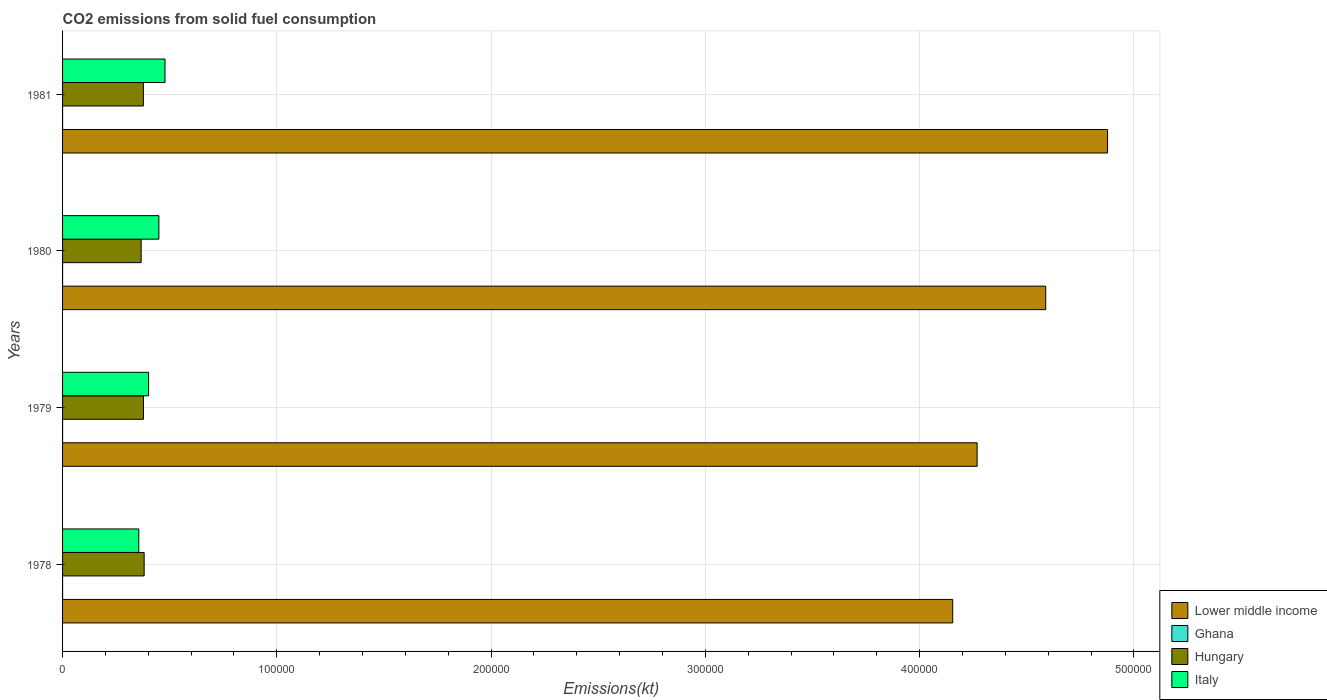How many groups of bars are there?
Offer a terse response. 4. How many bars are there on the 2nd tick from the bottom?
Give a very brief answer. 4. What is the label of the 1st group of bars from the top?
Your answer should be very brief. 1981. What is the amount of CO2 emitted in Ghana in 1980?
Give a very brief answer. 3.67. Across all years, what is the maximum amount of CO2 emitted in Ghana?
Provide a short and direct response. 3.67. Across all years, what is the minimum amount of CO2 emitted in Italy?
Keep it short and to the point. 3.56e+04. In which year was the amount of CO2 emitted in Lower middle income minimum?
Offer a very short reply. 1978. What is the total amount of CO2 emitted in Italy in the graph?
Ensure brevity in your answer.  1.68e+05. What is the difference between the amount of CO2 emitted in Hungary in 1980 and that in 1981?
Ensure brevity in your answer.  -1045.09. What is the difference between the amount of CO2 emitted in Lower middle income in 1981 and the amount of CO2 emitted in Hungary in 1979?
Provide a short and direct response. 4.50e+05. What is the average amount of CO2 emitted in Hungary per year?
Give a very brief answer. 3.76e+04. In the year 1980, what is the difference between the amount of CO2 emitted in Italy and amount of CO2 emitted in Ghana?
Keep it short and to the point. 4.49e+04. What is the ratio of the amount of CO2 emitted in Italy in 1978 to that in 1979?
Your answer should be very brief. 0.89. Is the amount of CO2 emitted in Ghana in 1978 less than that in 1979?
Offer a terse response. No. Is the difference between the amount of CO2 emitted in Italy in 1979 and 1980 greater than the difference between the amount of CO2 emitted in Ghana in 1979 and 1980?
Offer a very short reply. No. What is the difference between the highest and the second highest amount of CO2 emitted in Italy?
Provide a succinct answer. 2860.26. What is the difference between the highest and the lowest amount of CO2 emitted in Ghana?
Your answer should be very brief. 0. Is it the case that in every year, the sum of the amount of CO2 emitted in Ghana and amount of CO2 emitted in Hungary is greater than the sum of amount of CO2 emitted in Lower middle income and amount of CO2 emitted in Italy?
Your answer should be very brief. Yes. What does the 4th bar from the top in 1978 represents?
Your answer should be very brief. Lower middle income. What does the 3rd bar from the bottom in 1981 represents?
Your response must be concise. Hungary. Is it the case that in every year, the sum of the amount of CO2 emitted in Italy and amount of CO2 emitted in Ghana is greater than the amount of CO2 emitted in Hungary?
Your answer should be very brief. No. How many bars are there?
Your response must be concise. 16. Are all the bars in the graph horizontal?
Make the answer very short. Yes. What is the difference between two consecutive major ticks on the X-axis?
Offer a terse response. 1.00e+05. Are the values on the major ticks of X-axis written in scientific E-notation?
Offer a very short reply. No. Does the graph contain grids?
Offer a very short reply. Yes. What is the title of the graph?
Offer a terse response. CO2 emissions from solid fuel consumption. Does "Bahrain" appear as one of the legend labels in the graph?
Your answer should be very brief. No. What is the label or title of the X-axis?
Your answer should be compact. Emissions(kt). What is the label or title of the Y-axis?
Keep it short and to the point. Years. What is the Emissions(kt) of Lower middle income in 1978?
Your response must be concise. 4.15e+05. What is the Emissions(kt) of Ghana in 1978?
Your answer should be compact. 3.67. What is the Emissions(kt) of Hungary in 1978?
Your answer should be very brief. 3.81e+04. What is the Emissions(kt) of Italy in 1978?
Your response must be concise. 3.56e+04. What is the Emissions(kt) of Lower middle income in 1979?
Your response must be concise. 4.27e+05. What is the Emissions(kt) of Ghana in 1979?
Offer a terse response. 3.67. What is the Emissions(kt) of Hungary in 1979?
Offer a terse response. 3.78e+04. What is the Emissions(kt) of Italy in 1979?
Your response must be concise. 4.02e+04. What is the Emissions(kt) in Lower middle income in 1980?
Ensure brevity in your answer.  4.59e+05. What is the Emissions(kt) of Ghana in 1980?
Provide a succinct answer. 3.67. What is the Emissions(kt) of Hungary in 1980?
Give a very brief answer. 3.67e+04. What is the Emissions(kt) of Italy in 1980?
Ensure brevity in your answer.  4.50e+04. What is the Emissions(kt) of Lower middle income in 1981?
Offer a very short reply. 4.88e+05. What is the Emissions(kt) in Ghana in 1981?
Your response must be concise. 3.67. What is the Emissions(kt) in Hungary in 1981?
Make the answer very short. 3.77e+04. What is the Emissions(kt) in Italy in 1981?
Provide a succinct answer. 4.78e+04. Across all years, what is the maximum Emissions(kt) in Lower middle income?
Provide a succinct answer. 4.88e+05. Across all years, what is the maximum Emissions(kt) in Ghana?
Offer a very short reply. 3.67. Across all years, what is the maximum Emissions(kt) of Hungary?
Ensure brevity in your answer.  3.81e+04. Across all years, what is the maximum Emissions(kt) of Italy?
Offer a very short reply. 4.78e+04. Across all years, what is the minimum Emissions(kt) of Lower middle income?
Provide a short and direct response. 4.15e+05. Across all years, what is the minimum Emissions(kt) in Ghana?
Your answer should be very brief. 3.67. Across all years, what is the minimum Emissions(kt) of Hungary?
Your response must be concise. 3.67e+04. Across all years, what is the minimum Emissions(kt) in Italy?
Your response must be concise. 3.56e+04. What is the total Emissions(kt) of Lower middle income in the graph?
Your answer should be very brief. 1.79e+06. What is the total Emissions(kt) of Ghana in the graph?
Your response must be concise. 14.67. What is the total Emissions(kt) in Hungary in the graph?
Ensure brevity in your answer.  1.50e+05. What is the total Emissions(kt) of Italy in the graph?
Keep it short and to the point. 1.68e+05. What is the difference between the Emissions(kt) of Lower middle income in 1978 and that in 1979?
Provide a short and direct response. -1.14e+04. What is the difference between the Emissions(kt) in Ghana in 1978 and that in 1979?
Provide a succinct answer. 0. What is the difference between the Emissions(kt) in Hungary in 1978 and that in 1979?
Your response must be concise. 319.03. What is the difference between the Emissions(kt) of Italy in 1978 and that in 1979?
Your response must be concise. -4591.08. What is the difference between the Emissions(kt) of Lower middle income in 1978 and that in 1980?
Give a very brief answer. -4.34e+04. What is the difference between the Emissions(kt) in Ghana in 1978 and that in 1980?
Ensure brevity in your answer.  0. What is the difference between the Emissions(kt) in Hungary in 1978 and that in 1980?
Make the answer very short. 1400.79. What is the difference between the Emissions(kt) of Italy in 1978 and that in 1980?
Make the answer very short. -9380.19. What is the difference between the Emissions(kt) in Lower middle income in 1978 and that in 1981?
Your response must be concise. -7.23e+04. What is the difference between the Emissions(kt) in Ghana in 1978 and that in 1981?
Ensure brevity in your answer.  0. What is the difference between the Emissions(kt) of Hungary in 1978 and that in 1981?
Ensure brevity in your answer.  355.7. What is the difference between the Emissions(kt) of Italy in 1978 and that in 1981?
Give a very brief answer. -1.22e+04. What is the difference between the Emissions(kt) of Lower middle income in 1979 and that in 1980?
Give a very brief answer. -3.20e+04. What is the difference between the Emissions(kt) in Ghana in 1979 and that in 1980?
Your answer should be very brief. 0. What is the difference between the Emissions(kt) of Hungary in 1979 and that in 1980?
Your response must be concise. 1081.77. What is the difference between the Emissions(kt) in Italy in 1979 and that in 1980?
Offer a terse response. -4789.1. What is the difference between the Emissions(kt) of Lower middle income in 1979 and that in 1981?
Offer a terse response. -6.09e+04. What is the difference between the Emissions(kt) of Hungary in 1979 and that in 1981?
Give a very brief answer. 36.67. What is the difference between the Emissions(kt) of Italy in 1979 and that in 1981?
Make the answer very short. -7649.36. What is the difference between the Emissions(kt) of Lower middle income in 1980 and that in 1981?
Your answer should be very brief. -2.89e+04. What is the difference between the Emissions(kt) of Hungary in 1980 and that in 1981?
Provide a succinct answer. -1045.1. What is the difference between the Emissions(kt) in Italy in 1980 and that in 1981?
Keep it short and to the point. -2860.26. What is the difference between the Emissions(kt) of Lower middle income in 1978 and the Emissions(kt) of Ghana in 1979?
Provide a succinct answer. 4.15e+05. What is the difference between the Emissions(kt) of Lower middle income in 1978 and the Emissions(kt) of Hungary in 1979?
Your response must be concise. 3.78e+05. What is the difference between the Emissions(kt) in Lower middle income in 1978 and the Emissions(kt) in Italy in 1979?
Provide a succinct answer. 3.75e+05. What is the difference between the Emissions(kt) in Ghana in 1978 and the Emissions(kt) in Hungary in 1979?
Offer a terse response. -3.78e+04. What is the difference between the Emissions(kt) in Ghana in 1978 and the Emissions(kt) in Italy in 1979?
Ensure brevity in your answer.  -4.02e+04. What is the difference between the Emissions(kt) of Hungary in 1978 and the Emissions(kt) of Italy in 1979?
Provide a succinct answer. -2082.86. What is the difference between the Emissions(kt) in Lower middle income in 1978 and the Emissions(kt) in Ghana in 1980?
Your answer should be very brief. 4.15e+05. What is the difference between the Emissions(kt) of Lower middle income in 1978 and the Emissions(kt) of Hungary in 1980?
Your answer should be compact. 3.79e+05. What is the difference between the Emissions(kt) in Lower middle income in 1978 and the Emissions(kt) in Italy in 1980?
Offer a terse response. 3.70e+05. What is the difference between the Emissions(kt) in Ghana in 1978 and the Emissions(kt) in Hungary in 1980?
Provide a succinct answer. -3.67e+04. What is the difference between the Emissions(kt) of Ghana in 1978 and the Emissions(kt) of Italy in 1980?
Offer a very short reply. -4.49e+04. What is the difference between the Emissions(kt) of Hungary in 1978 and the Emissions(kt) of Italy in 1980?
Offer a very short reply. -6871.96. What is the difference between the Emissions(kt) in Lower middle income in 1978 and the Emissions(kt) in Ghana in 1981?
Offer a terse response. 4.15e+05. What is the difference between the Emissions(kt) of Lower middle income in 1978 and the Emissions(kt) of Hungary in 1981?
Your response must be concise. 3.78e+05. What is the difference between the Emissions(kt) of Lower middle income in 1978 and the Emissions(kt) of Italy in 1981?
Provide a short and direct response. 3.68e+05. What is the difference between the Emissions(kt) of Ghana in 1978 and the Emissions(kt) of Hungary in 1981?
Make the answer very short. -3.77e+04. What is the difference between the Emissions(kt) in Ghana in 1978 and the Emissions(kt) in Italy in 1981?
Your answer should be compact. -4.78e+04. What is the difference between the Emissions(kt) of Hungary in 1978 and the Emissions(kt) of Italy in 1981?
Give a very brief answer. -9732.22. What is the difference between the Emissions(kt) in Lower middle income in 1979 and the Emissions(kt) in Ghana in 1980?
Offer a terse response. 4.27e+05. What is the difference between the Emissions(kt) of Lower middle income in 1979 and the Emissions(kt) of Hungary in 1980?
Keep it short and to the point. 3.90e+05. What is the difference between the Emissions(kt) of Lower middle income in 1979 and the Emissions(kt) of Italy in 1980?
Offer a very short reply. 3.82e+05. What is the difference between the Emissions(kt) of Ghana in 1979 and the Emissions(kt) of Hungary in 1980?
Provide a succinct answer. -3.67e+04. What is the difference between the Emissions(kt) in Ghana in 1979 and the Emissions(kt) in Italy in 1980?
Give a very brief answer. -4.49e+04. What is the difference between the Emissions(kt) of Hungary in 1979 and the Emissions(kt) of Italy in 1980?
Offer a very short reply. -7190.99. What is the difference between the Emissions(kt) of Lower middle income in 1979 and the Emissions(kt) of Ghana in 1981?
Keep it short and to the point. 4.27e+05. What is the difference between the Emissions(kt) of Lower middle income in 1979 and the Emissions(kt) of Hungary in 1981?
Your response must be concise. 3.89e+05. What is the difference between the Emissions(kt) of Lower middle income in 1979 and the Emissions(kt) of Italy in 1981?
Keep it short and to the point. 3.79e+05. What is the difference between the Emissions(kt) of Ghana in 1979 and the Emissions(kt) of Hungary in 1981?
Your answer should be compact. -3.77e+04. What is the difference between the Emissions(kt) in Ghana in 1979 and the Emissions(kt) in Italy in 1981?
Provide a succinct answer. -4.78e+04. What is the difference between the Emissions(kt) of Hungary in 1979 and the Emissions(kt) of Italy in 1981?
Give a very brief answer. -1.01e+04. What is the difference between the Emissions(kt) of Lower middle income in 1980 and the Emissions(kt) of Ghana in 1981?
Offer a very short reply. 4.59e+05. What is the difference between the Emissions(kt) of Lower middle income in 1980 and the Emissions(kt) of Hungary in 1981?
Offer a very short reply. 4.21e+05. What is the difference between the Emissions(kt) of Lower middle income in 1980 and the Emissions(kt) of Italy in 1981?
Your answer should be compact. 4.11e+05. What is the difference between the Emissions(kt) in Ghana in 1980 and the Emissions(kt) in Hungary in 1981?
Your answer should be very brief. -3.77e+04. What is the difference between the Emissions(kt) in Ghana in 1980 and the Emissions(kt) in Italy in 1981?
Your answer should be very brief. -4.78e+04. What is the difference between the Emissions(kt) in Hungary in 1980 and the Emissions(kt) in Italy in 1981?
Provide a succinct answer. -1.11e+04. What is the average Emissions(kt) of Lower middle income per year?
Offer a terse response. 4.47e+05. What is the average Emissions(kt) in Ghana per year?
Your answer should be compact. 3.67. What is the average Emissions(kt) in Hungary per year?
Ensure brevity in your answer.  3.76e+04. What is the average Emissions(kt) of Italy per year?
Ensure brevity in your answer.  4.21e+04. In the year 1978, what is the difference between the Emissions(kt) of Lower middle income and Emissions(kt) of Ghana?
Give a very brief answer. 4.15e+05. In the year 1978, what is the difference between the Emissions(kt) of Lower middle income and Emissions(kt) of Hungary?
Ensure brevity in your answer.  3.77e+05. In the year 1978, what is the difference between the Emissions(kt) in Lower middle income and Emissions(kt) in Italy?
Offer a terse response. 3.80e+05. In the year 1978, what is the difference between the Emissions(kt) of Ghana and Emissions(kt) of Hungary?
Your answer should be compact. -3.81e+04. In the year 1978, what is the difference between the Emissions(kt) of Ghana and Emissions(kt) of Italy?
Your answer should be very brief. -3.56e+04. In the year 1978, what is the difference between the Emissions(kt) of Hungary and Emissions(kt) of Italy?
Your answer should be compact. 2508.23. In the year 1979, what is the difference between the Emissions(kt) in Lower middle income and Emissions(kt) in Ghana?
Provide a short and direct response. 4.27e+05. In the year 1979, what is the difference between the Emissions(kt) in Lower middle income and Emissions(kt) in Hungary?
Give a very brief answer. 3.89e+05. In the year 1979, what is the difference between the Emissions(kt) in Lower middle income and Emissions(kt) in Italy?
Provide a succinct answer. 3.87e+05. In the year 1979, what is the difference between the Emissions(kt) of Ghana and Emissions(kt) of Hungary?
Keep it short and to the point. -3.78e+04. In the year 1979, what is the difference between the Emissions(kt) of Ghana and Emissions(kt) of Italy?
Your answer should be compact. -4.02e+04. In the year 1979, what is the difference between the Emissions(kt) of Hungary and Emissions(kt) of Italy?
Keep it short and to the point. -2401.89. In the year 1980, what is the difference between the Emissions(kt) of Lower middle income and Emissions(kt) of Ghana?
Your answer should be compact. 4.59e+05. In the year 1980, what is the difference between the Emissions(kt) in Lower middle income and Emissions(kt) in Hungary?
Offer a very short reply. 4.22e+05. In the year 1980, what is the difference between the Emissions(kt) of Lower middle income and Emissions(kt) of Italy?
Your response must be concise. 4.14e+05. In the year 1980, what is the difference between the Emissions(kt) of Ghana and Emissions(kt) of Hungary?
Your answer should be compact. -3.67e+04. In the year 1980, what is the difference between the Emissions(kt) of Ghana and Emissions(kt) of Italy?
Your answer should be very brief. -4.49e+04. In the year 1980, what is the difference between the Emissions(kt) of Hungary and Emissions(kt) of Italy?
Your answer should be very brief. -8272.75. In the year 1981, what is the difference between the Emissions(kt) in Lower middle income and Emissions(kt) in Ghana?
Offer a very short reply. 4.88e+05. In the year 1981, what is the difference between the Emissions(kt) of Lower middle income and Emissions(kt) of Hungary?
Ensure brevity in your answer.  4.50e+05. In the year 1981, what is the difference between the Emissions(kt) of Lower middle income and Emissions(kt) of Italy?
Your answer should be very brief. 4.40e+05. In the year 1981, what is the difference between the Emissions(kt) in Ghana and Emissions(kt) in Hungary?
Ensure brevity in your answer.  -3.77e+04. In the year 1981, what is the difference between the Emissions(kt) of Ghana and Emissions(kt) of Italy?
Your answer should be compact. -4.78e+04. In the year 1981, what is the difference between the Emissions(kt) in Hungary and Emissions(kt) in Italy?
Offer a terse response. -1.01e+04. What is the ratio of the Emissions(kt) in Lower middle income in 1978 to that in 1979?
Your answer should be very brief. 0.97. What is the ratio of the Emissions(kt) of Hungary in 1978 to that in 1979?
Your answer should be very brief. 1.01. What is the ratio of the Emissions(kt) in Italy in 1978 to that in 1979?
Provide a short and direct response. 0.89. What is the ratio of the Emissions(kt) in Lower middle income in 1978 to that in 1980?
Your response must be concise. 0.91. What is the ratio of the Emissions(kt) in Hungary in 1978 to that in 1980?
Your response must be concise. 1.04. What is the ratio of the Emissions(kt) of Italy in 1978 to that in 1980?
Provide a short and direct response. 0.79. What is the ratio of the Emissions(kt) of Lower middle income in 1978 to that in 1981?
Your response must be concise. 0.85. What is the ratio of the Emissions(kt) in Hungary in 1978 to that in 1981?
Your response must be concise. 1.01. What is the ratio of the Emissions(kt) in Italy in 1978 to that in 1981?
Keep it short and to the point. 0.74. What is the ratio of the Emissions(kt) of Lower middle income in 1979 to that in 1980?
Offer a very short reply. 0.93. What is the ratio of the Emissions(kt) in Hungary in 1979 to that in 1980?
Your answer should be very brief. 1.03. What is the ratio of the Emissions(kt) in Italy in 1979 to that in 1980?
Your response must be concise. 0.89. What is the ratio of the Emissions(kt) of Lower middle income in 1979 to that in 1981?
Provide a succinct answer. 0.88. What is the ratio of the Emissions(kt) in Ghana in 1979 to that in 1981?
Provide a short and direct response. 1. What is the ratio of the Emissions(kt) of Italy in 1979 to that in 1981?
Offer a terse response. 0.84. What is the ratio of the Emissions(kt) of Lower middle income in 1980 to that in 1981?
Ensure brevity in your answer.  0.94. What is the ratio of the Emissions(kt) of Hungary in 1980 to that in 1981?
Give a very brief answer. 0.97. What is the ratio of the Emissions(kt) in Italy in 1980 to that in 1981?
Your answer should be very brief. 0.94. What is the difference between the highest and the second highest Emissions(kt) of Lower middle income?
Your answer should be compact. 2.89e+04. What is the difference between the highest and the second highest Emissions(kt) of Hungary?
Offer a terse response. 319.03. What is the difference between the highest and the second highest Emissions(kt) in Italy?
Make the answer very short. 2860.26. What is the difference between the highest and the lowest Emissions(kt) in Lower middle income?
Your answer should be compact. 7.23e+04. What is the difference between the highest and the lowest Emissions(kt) in Ghana?
Give a very brief answer. 0. What is the difference between the highest and the lowest Emissions(kt) of Hungary?
Your response must be concise. 1400.79. What is the difference between the highest and the lowest Emissions(kt) of Italy?
Provide a succinct answer. 1.22e+04. 